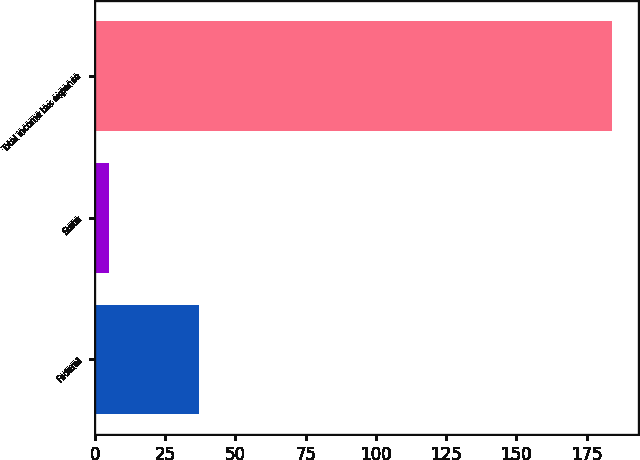Convert chart to OTSL. <chart><loc_0><loc_0><loc_500><loc_500><bar_chart><fcel>Federal<fcel>State<fcel>Total income tax expense<nl><fcel>37<fcel>5<fcel>184<nl></chart> 